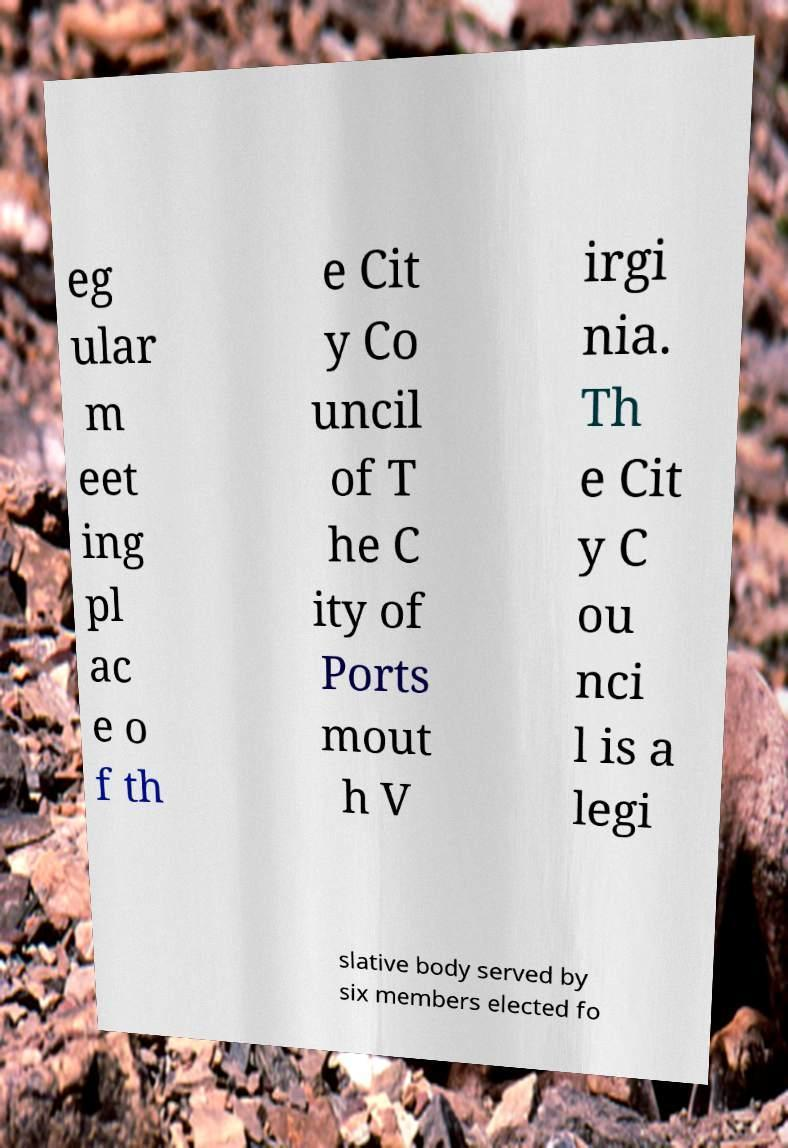There's text embedded in this image that I need extracted. Can you transcribe it verbatim? eg ular m eet ing pl ac e o f th e Cit y Co uncil of T he C ity of Ports mout h V irgi nia. Th e Cit y C ou nci l is a legi slative body served by six members elected fo 